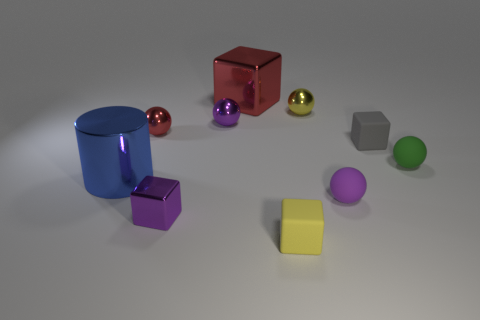There is a gray thing that is made of the same material as the yellow cube; what is its size?
Give a very brief answer. Small. Is the number of tiny gray rubber things that are behind the tiny gray matte thing greater than the number of large green matte cylinders?
Offer a terse response. No. There is a thing that is left of the purple metallic cube and behind the big blue metal cylinder; what size is it?
Your answer should be very brief. Small. What is the material of the tiny yellow thing that is the same shape as the small red thing?
Offer a terse response. Metal. Does the red shiny thing that is on the left side of the purple metallic ball have the same size as the small purple matte sphere?
Provide a succinct answer. Yes. What color is the rubber thing that is both in front of the shiny cylinder and behind the yellow block?
Keep it short and to the point. Purple. What number of matte balls are behind the large metal thing that is in front of the small green matte thing?
Provide a succinct answer. 1. Does the tiny red object have the same shape as the blue metal thing?
Give a very brief answer. No. Is there anything else that is the same color as the large block?
Offer a terse response. Yes. There is a big red metal object; does it have the same shape as the purple metallic thing that is behind the purple cube?
Make the answer very short. No. 